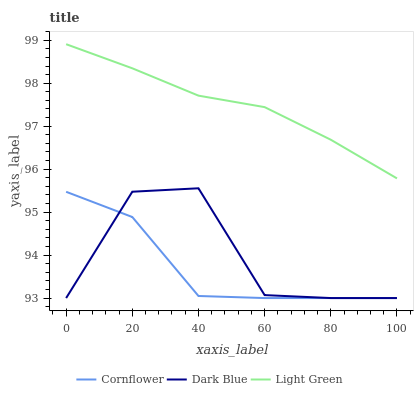Does Cornflower have the minimum area under the curve?
Answer yes or no. Yes. Does Light Green have the maximum area under the curve?
Answer yes or no. Yes. Does Dark Blue have the minimum area under the curve?
Answer yes or no. No. Does Dark Blue have the maximum area under the curve?
Answer yes or no. No. Is Light Green the smoothest?
Answer yes or no. Yes. Is Dark Blue the roughest?
Answer yes or no. Yes. Is Dark Blue the smoothest?
Answer yes or no. No. Is Light Green the roughest?
Answer yes or no. No. Does Cornflower have the lowest value?
Answer yes or no. Yes. Does Light Green have the lowest value?
Answer yes or no. No. Does Light Green have the highest value?
Answer yes or no. Yes. Does Dark Blue have the highest value?
Answer yes or no. No. Is Cornflower less than Light Green?
Answer yes or no. Yes. Is Light Green greater than Cornflower?
Answer yes or no. Yes. Does Cornflower intersect Dark Blue?
Answer yes or no. Yes. Is Cornflower less than Dark Blue?
Answer yes or no. No. Is Cornflower greater than Dark Blue?
Answer yes or no. No. Does Cornflower intersect Light Green?
Answer yes or no. No. 